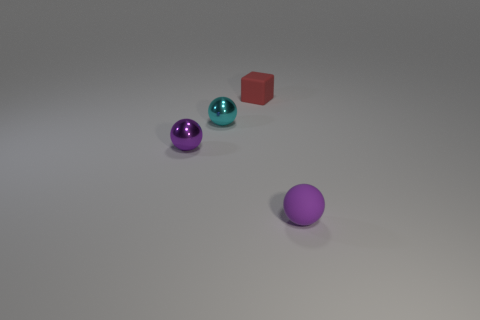What is the shape of the tiny thing that is both behind the small purple metallic ball and to the left of the red cube?
Offer a very short reply. Sphere. Does the red block have the same material as the ball on the right side of the small red rubber object?
Your answer should be compact. Yes. Are there any tiny rubber things behind the small red object?
Ensure brevity in your answer.  No. How many objects are big blue metallic objects or small purple objects left of the tiny cube?
Offer a very short reply. 1. What is the color of the tiny rubber object that is in front of the purple thing left of the red thing?
Make the answer very short. Purple. How many other objects are the same material as the tiny block?
Your answer should be compact. 1. What number of rubber objects are either purple cylinders or balls?
Offer a very short reply. 1. What color is the other shiny object that is the same shape as the cyan thing?
Your answer should be compact. Purple. What number of objects are either small yellow rubber blocks or purple matte things?
Offer a very short reply. 1. What shape is the other thing that is made of the same material as the small cyan thing?
Provide a succinct answer. Sphere. 